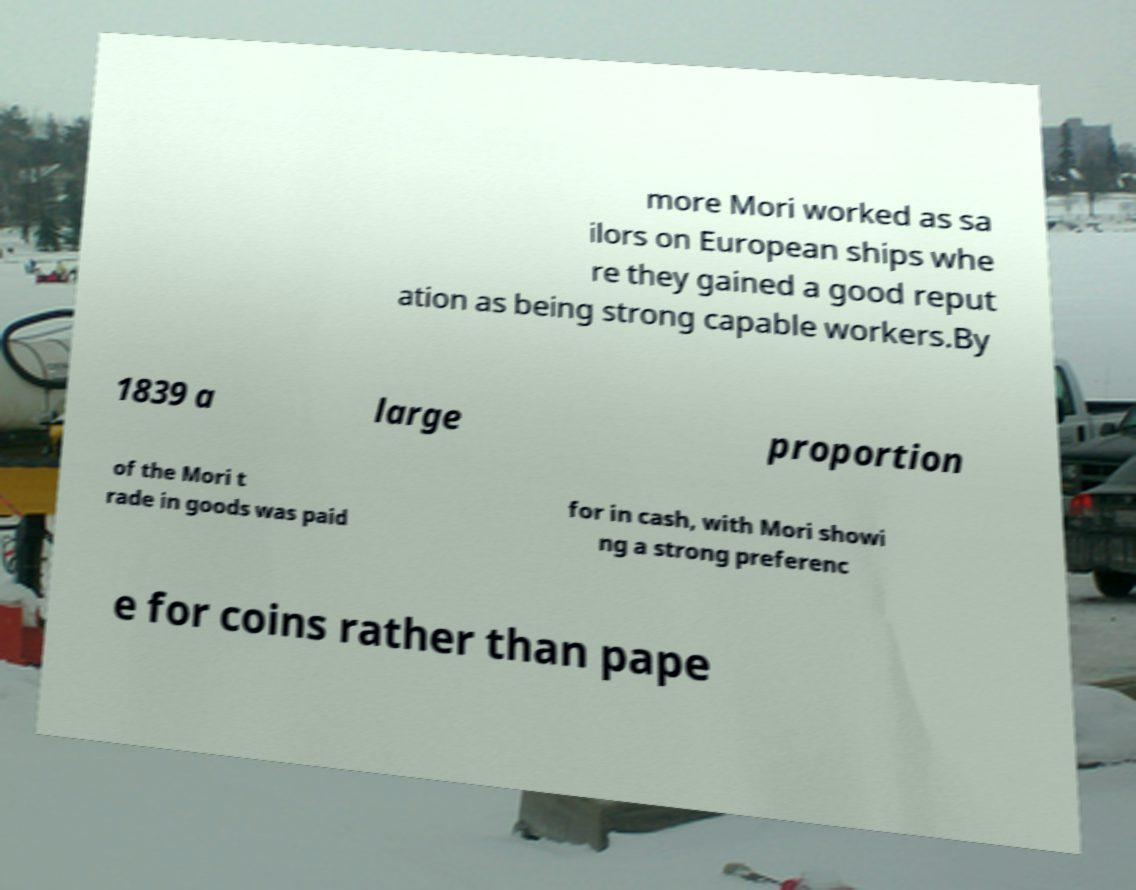For documentation purposes, I need the text within this image transcribed. Could you provide that? more Mori worked as sa ilors on European ships whe re they gained a good reput ation as being strong capable workers.By 1839 a large proportion of the Mori t rade in goods was paid for in cash, with Mori showi ng a strong preferenc e for coins rather than pape 